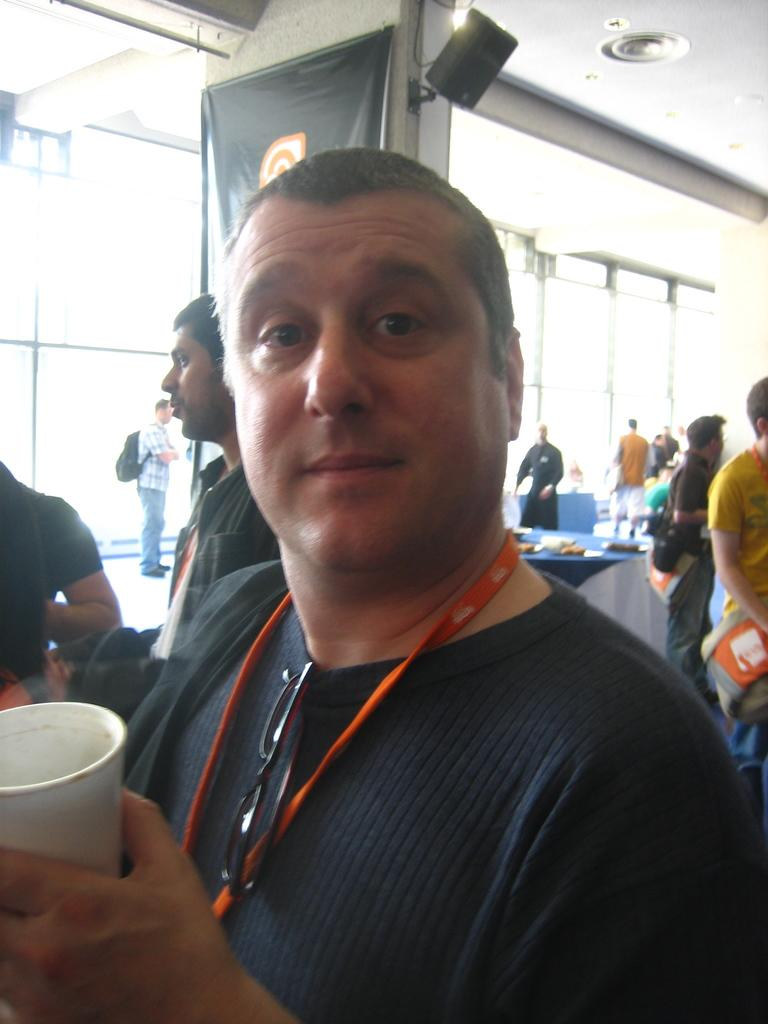What is the man in the image holding? The man is holding a glass in the image. What can be seen in the background of the image? There is a group of people in the background of the image. What is on the table in the image? There is a table with objects on it in the image. What is hanging or displayed in the image? There is a banner in the image. What is used for amplifying sound in the image? There is a speaker box in the image. What structure is visible in the image? There is a roof visible in the image. What type of spark can be seen coming from the glass in the image? There is no spark visible in the image, as the man is simply holding a glass. 